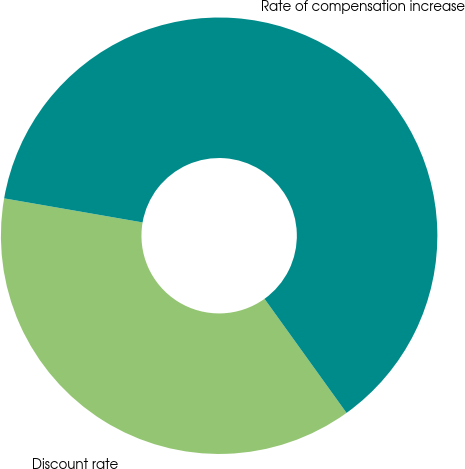Convert chart. <chart><loc_0><loc_0><loc_500><loc_500><pie_chart><fcel>Discount rate<fcel>Rate of compensation increase<nl><fcel>37.66%<fcel>62.34%<nl></chart> 